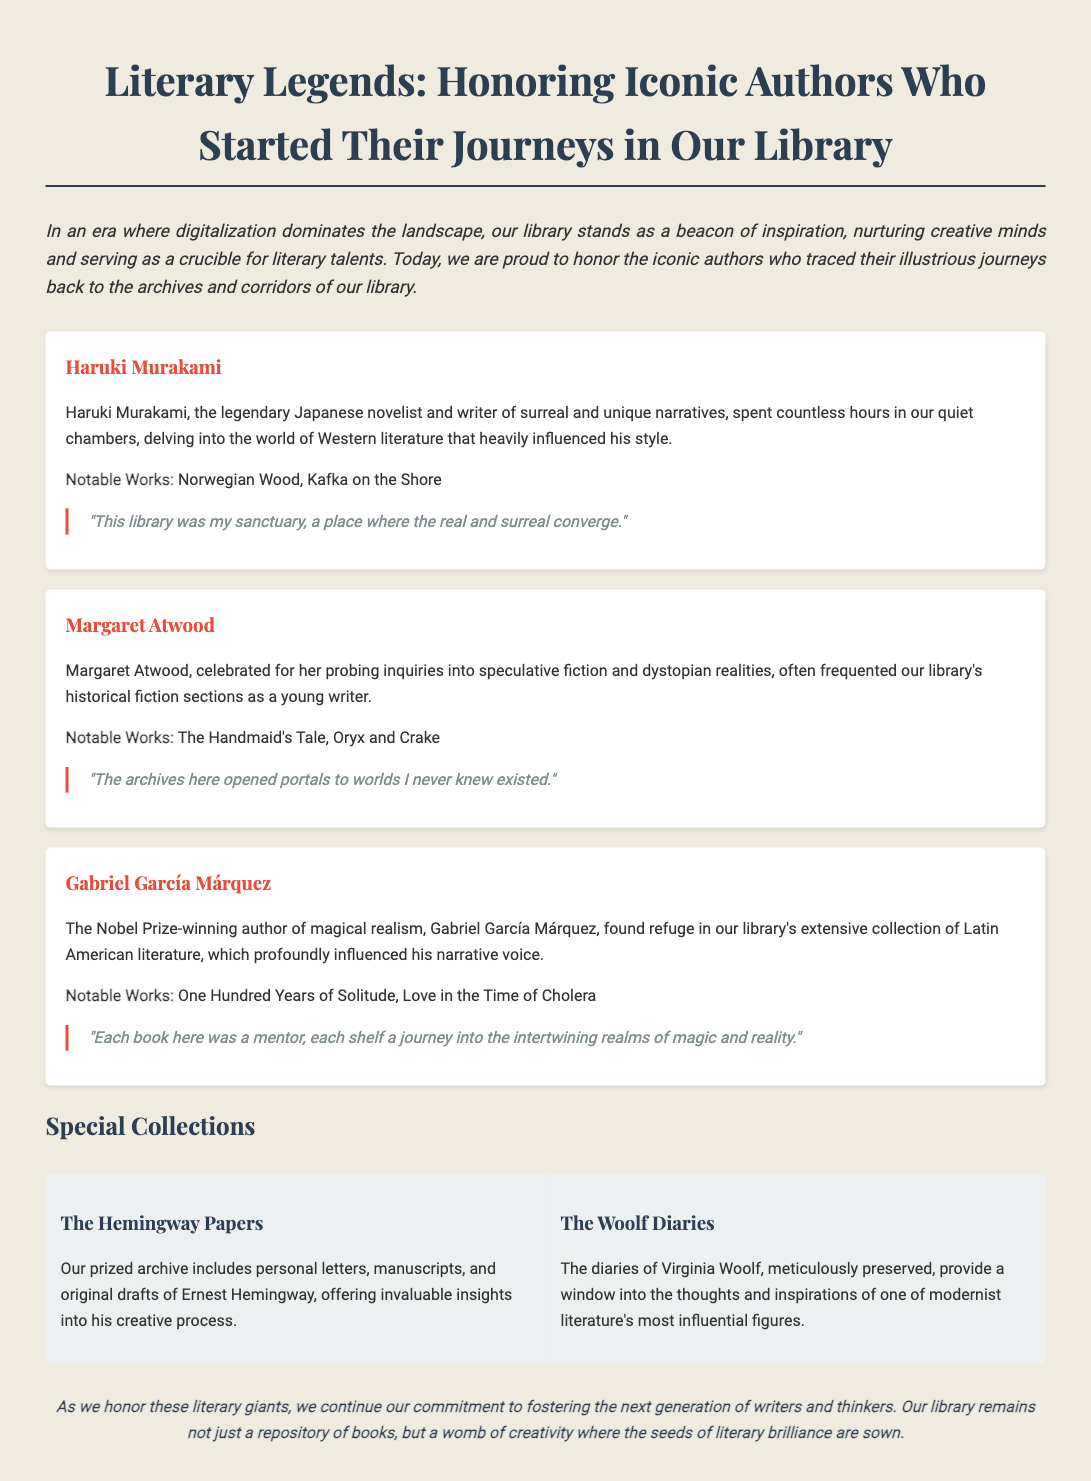What is the title of the press release? The title of the press release is prominently displayed at the top of the document.
Answer: Literary Legends: Honoring Iconic Authors Who Started Their Journeys in Our Library Who is an iconic author mentioned alongside Haruki Murakami? The document provides a list of authors, and one is highlighted after Murakami.
Answer: Margaret Atwood What is a notable work of Gabriel García Márquez? The document lists notable works associated with each author, including Márquez.
Answer: One Hundred Years of Solitude Which special collection is mentioned in the document? The document lists specific special collections related to famous authors.
Answer: The Hemingway Papers What genre does Margaret Atwood primarily explore? The document describes Atwood's contributions to literature and highlights her focus area.
Answer: Speculative fiction 